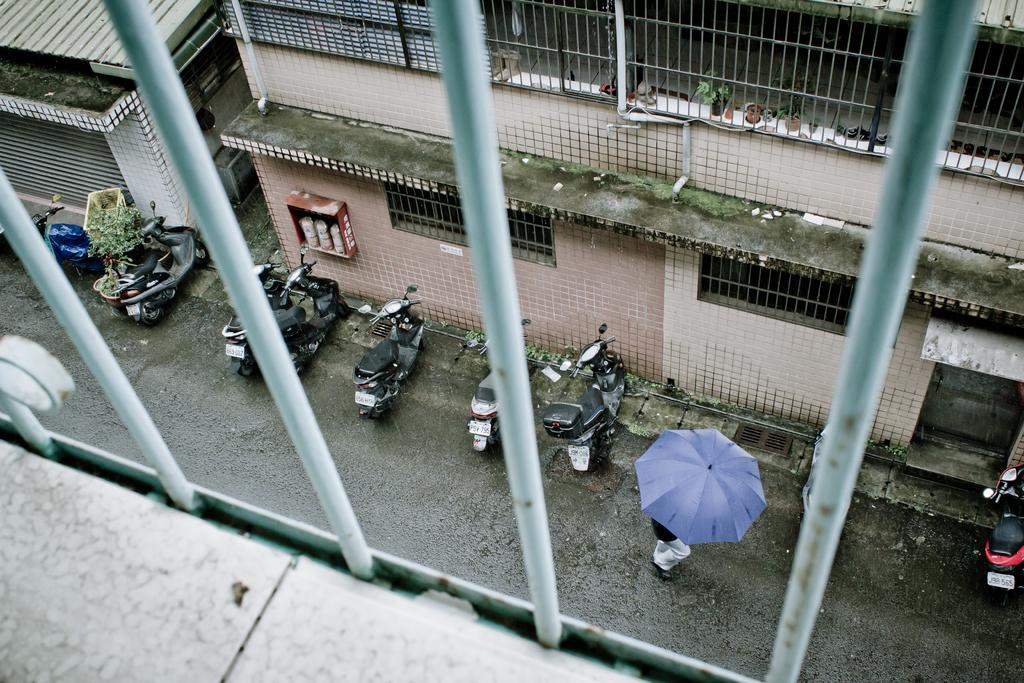What type of structures can be seen in the image? There are buildings in the image. What mode of transportation is present on the road? Motorcycles are placed on the road. Can you describe the person in the image? There is a person holding an umbrella. What architectural feature is visible in the image? Grilles are visible in the image. What hobbies does the person holding the umbrella enjoy in the image? There is no information about the person's hobbies in the image. What type of skin condition can be seen on the person holding the umbrella? There is no information about the person's skin condition in the image. 